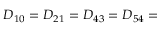Convert formula to latex. <formula><loc_0><loc_0><loc_500><loc_500>D _ { 1 0 } = D _ { 2 1 } = D _ { 4 3 } = D _ { 5 4 } =</formula> 